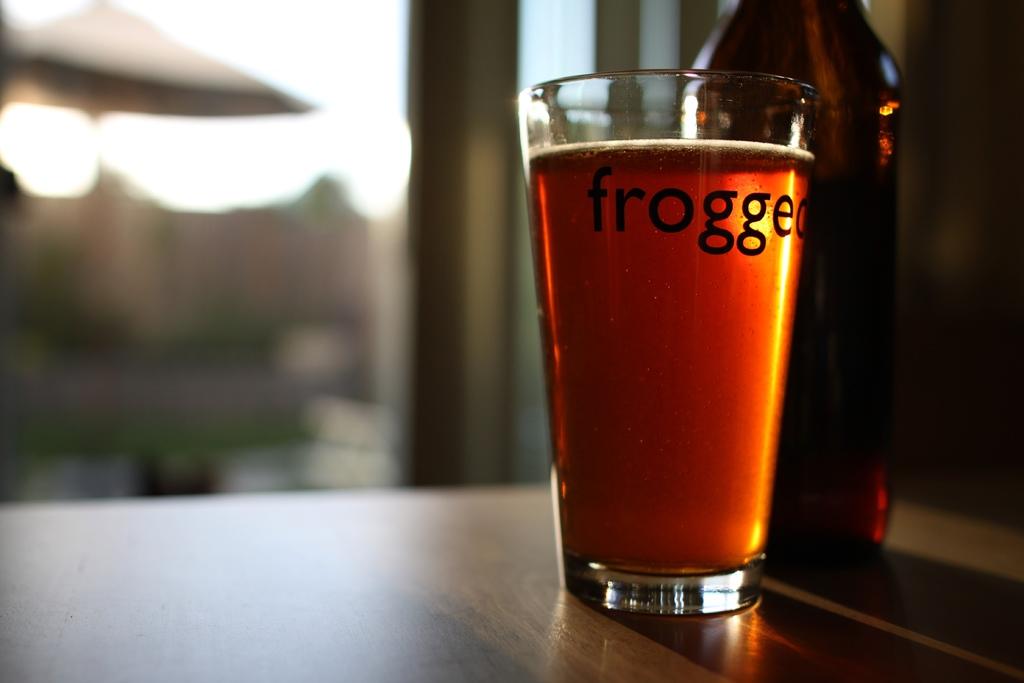What kind of beer is this?
Give a very brief answer. Frogged. 